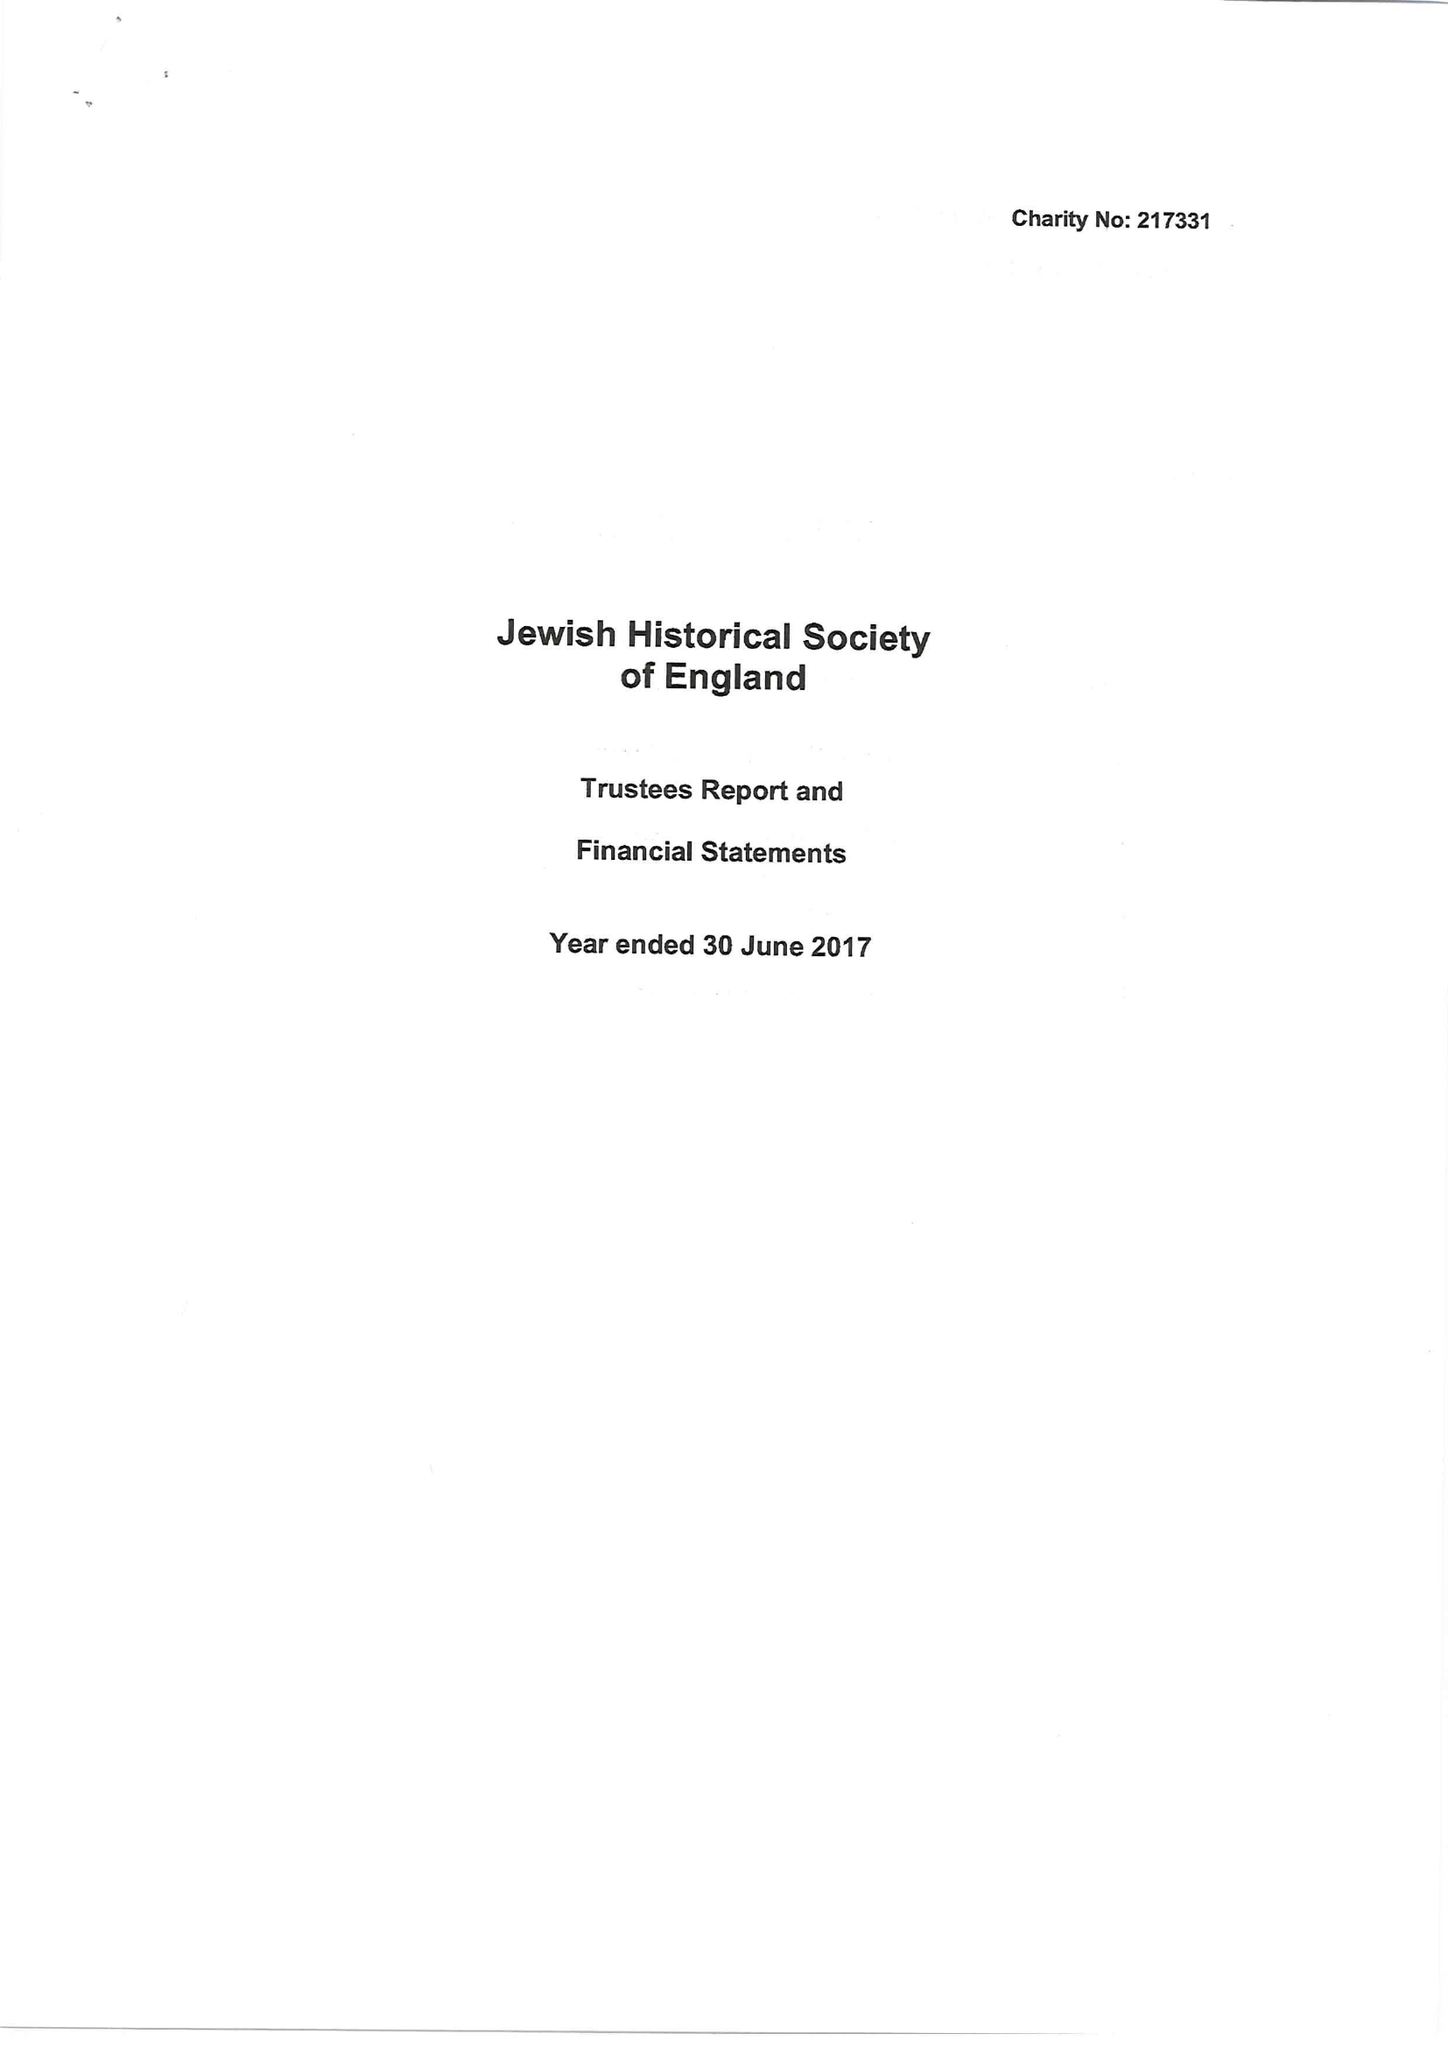What is the value for the income_annually_in_british_pounds?
Answer the question using a single word or phrase. 60811.00 